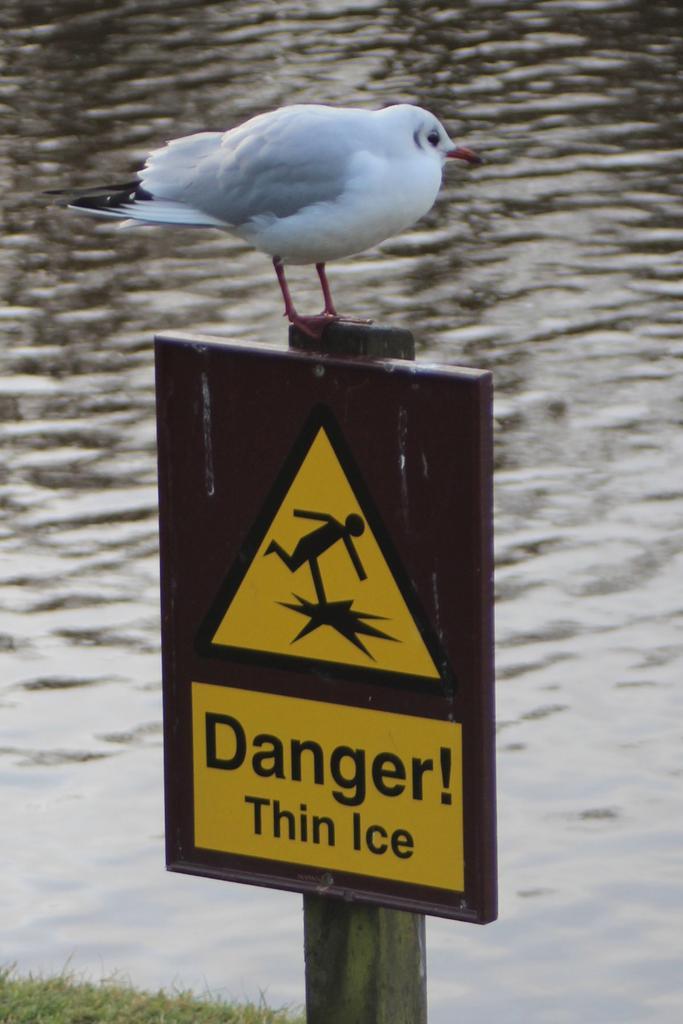Please provide a concise description of this image. This picture shows a bird on the caution board and we see water and grass on the ground. The bird is white and black in color. 